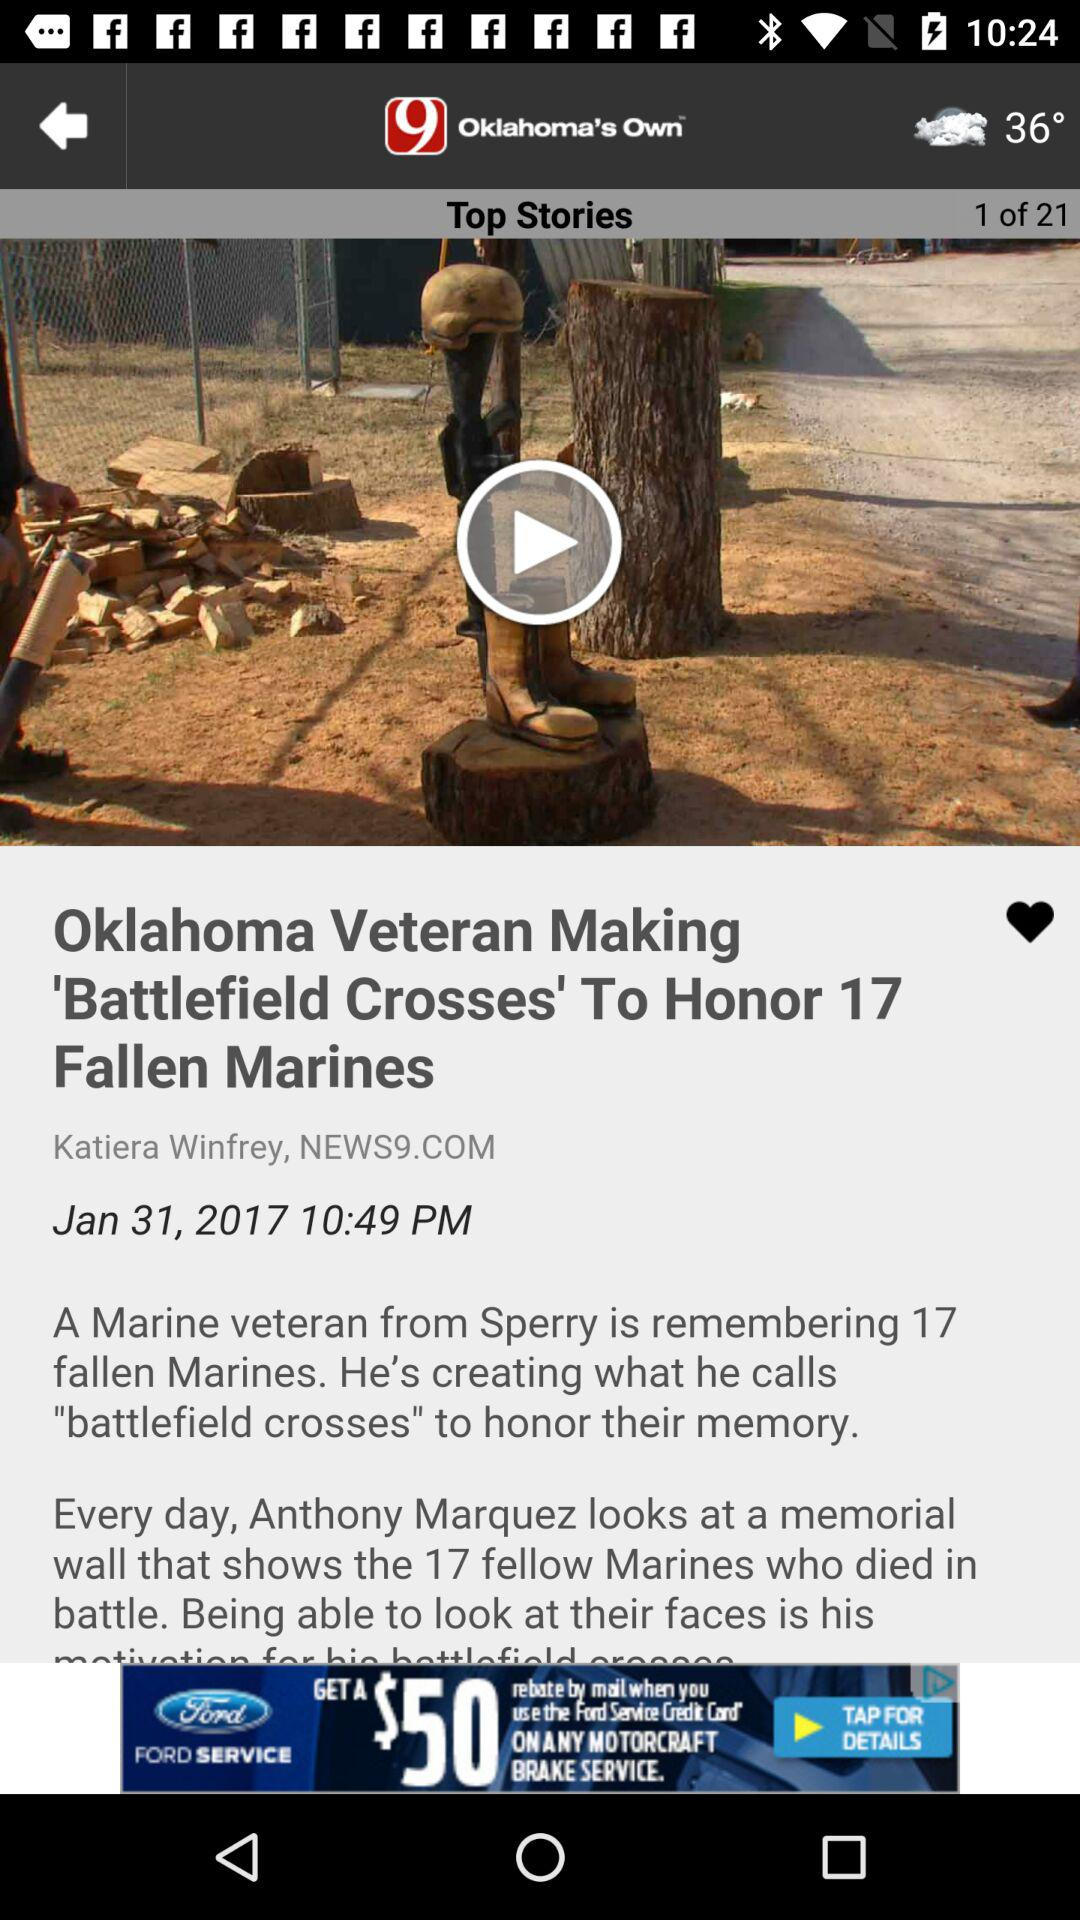What is the date? The date is Jan 31, 2017. 